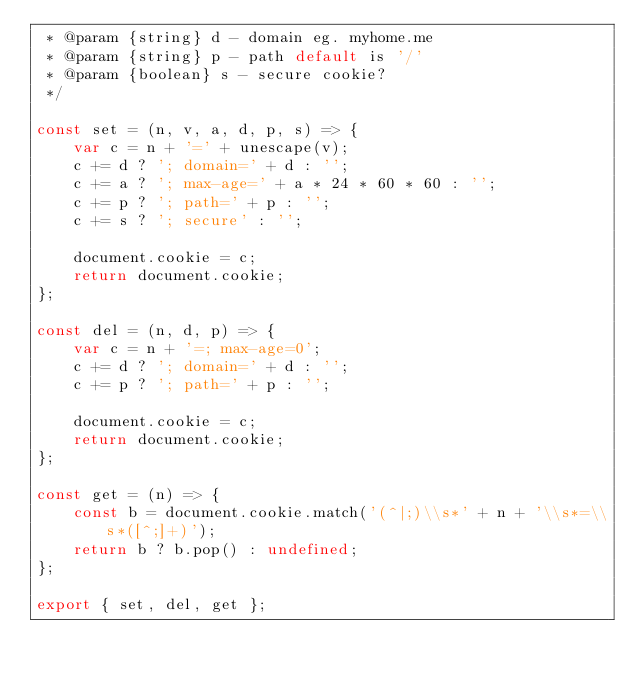<code> <loc_0><loc_0><loc_500><loc_500><_JavaScript_> * @param {string} d - domain eg. myhome.me
 * @param {string} p - path default is '/'
 * @param {boolean} s - secure cookie?
 */

const set = (n, v, a, d, p, s) => {
	var c = n + '=' + unescape(v);
	c += d ? '; domain=' + d : '';
	c += a ? '; max-age=' + a * 24 * 60 * 60 : '';
	c += p ? '; path=' + p : '';
	c += s ? '; secure' : '';

	document.cookie = c;
	return document.cookie;
};

const del = (n, d, p) => {
	var c = n + '=; max-age=0';
	c += d ? '; domain=' + d : '';
	c += p ? '; path=' + p : '';

	document.cookie = c;
	return document.cookie;
};

const get = (n) => {
	const b = document.cookie.match('(^|;)\\s*' + n + '\\s*=\\s*([^;]+)');
	return b ? b.pop() : undefined;
};

export { set, del, get };
</code> 